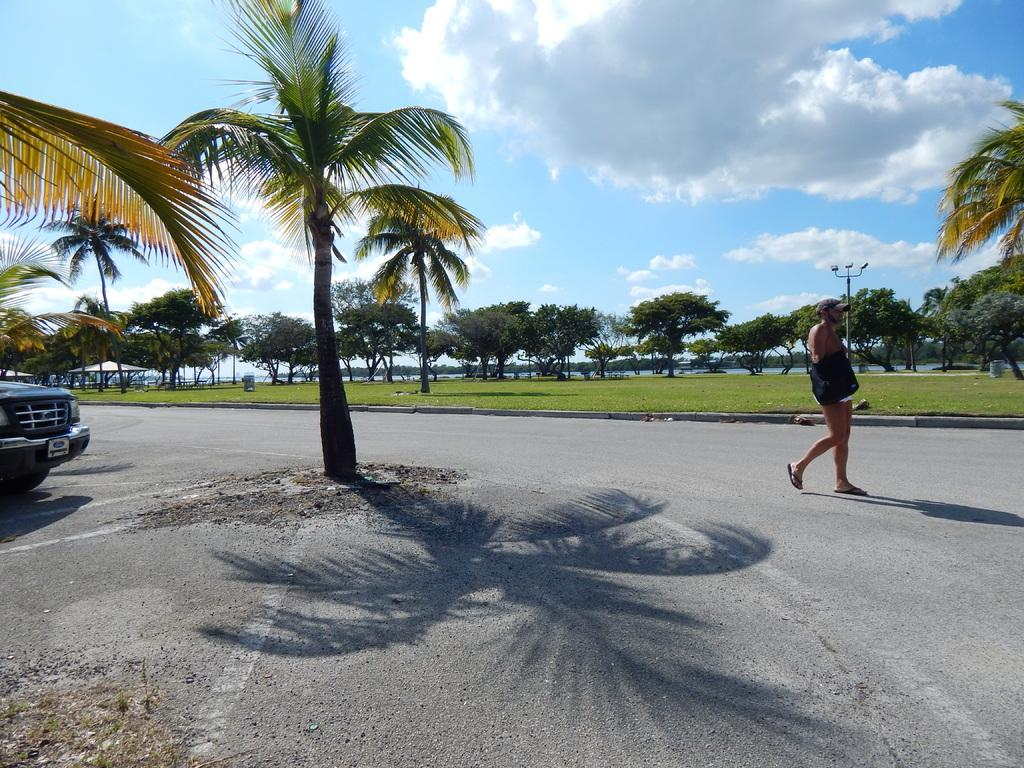What is the man in the image doing? The man is walking in the image. Where is the man located in the image? The man is on the road in the image. What else can be seen on the road in the image? There is a vehicle on the left side of the image. What can be seen in the background of the image? There are trees and clouds in the sky in the background of the image. What type of whistle can be heard coming from the trees in the image? There is no whistle present in the image, and no sound can be heard from the trees. 